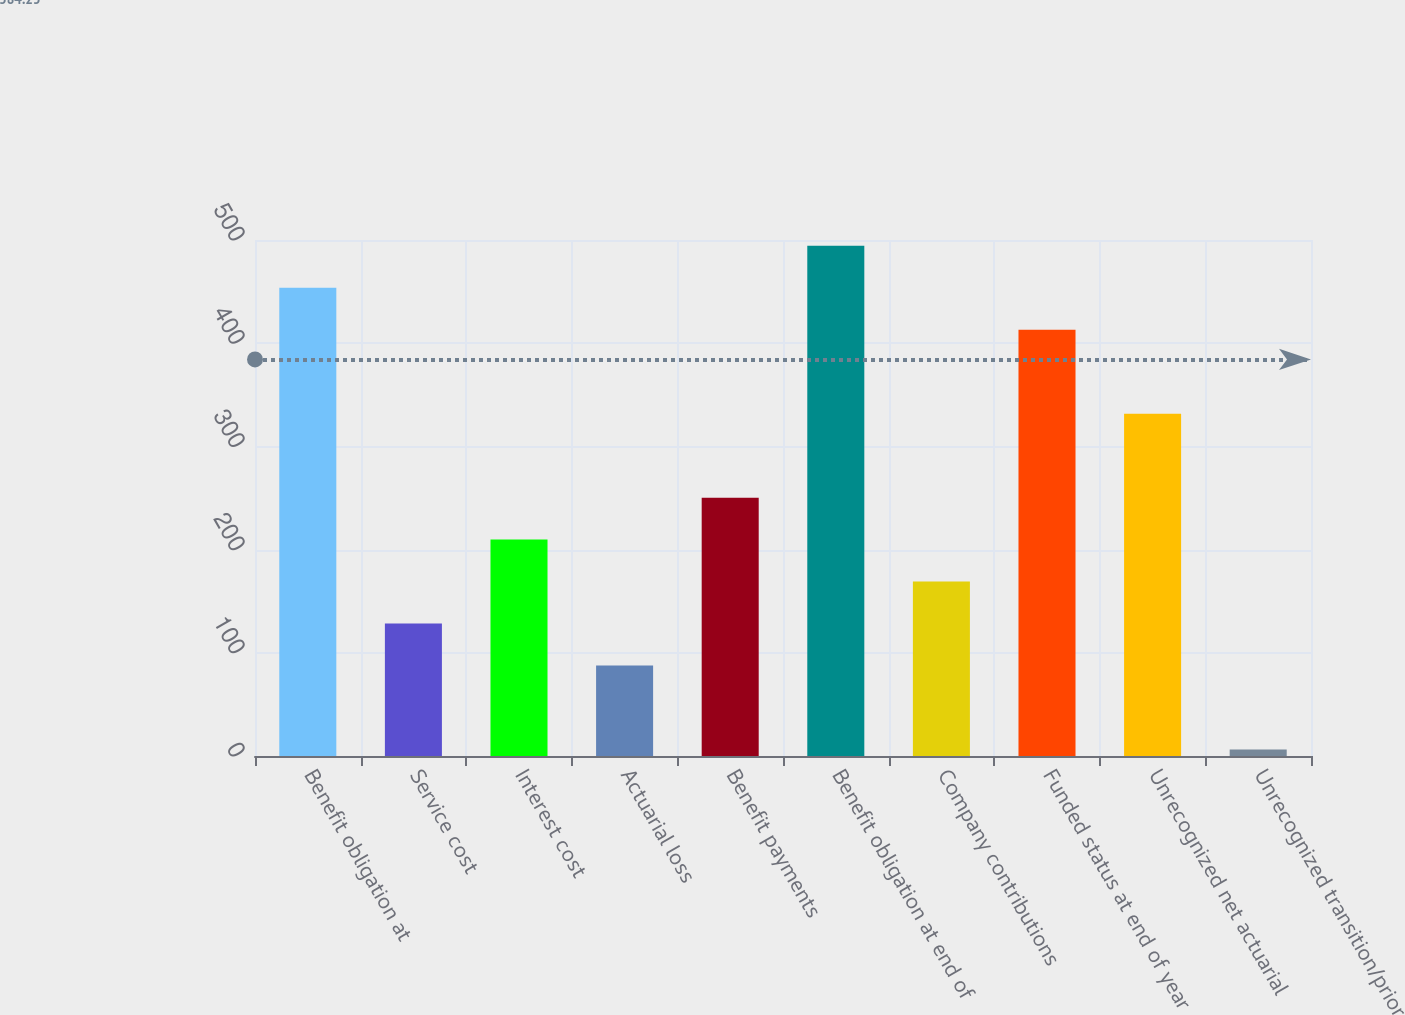Convert chart to OTSL. <chart><loc_0><loc_0><loc_500><loc_500><bar_chart><fcel>Benefit obligation at<fcel>Service cost<fcel>Interest cost<fcel>Actuarial loss<fcel>Benefit payments<fcel>Benefit obligation at end of<fcel>Company contributions<fcel>Funded status at end of year<fcel>Unrecognized net actuarial<fcel>Unrecognized transition/prior<nl><fcel>453.66<fcel>128.38<fcel>209.7<fcel>87.72<fcel>250.36<fcel>494.32<fcel>169.04<fcel>413<fcel>331.68<fcel>6.4<nl></chart> 